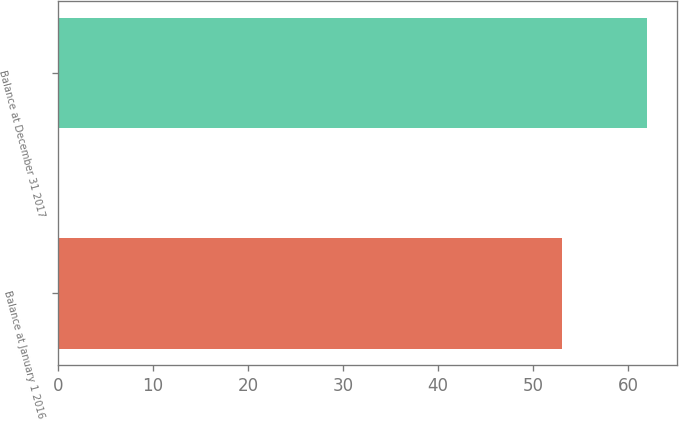Convert chart. <chart><loc_0><loc_0><loc_500><loc_500><bar_chart><fcel>Balance at January 1 2016<fcel>Balance at December 31 2017<nl><fcel>53<fcel>62<nl></chart> 